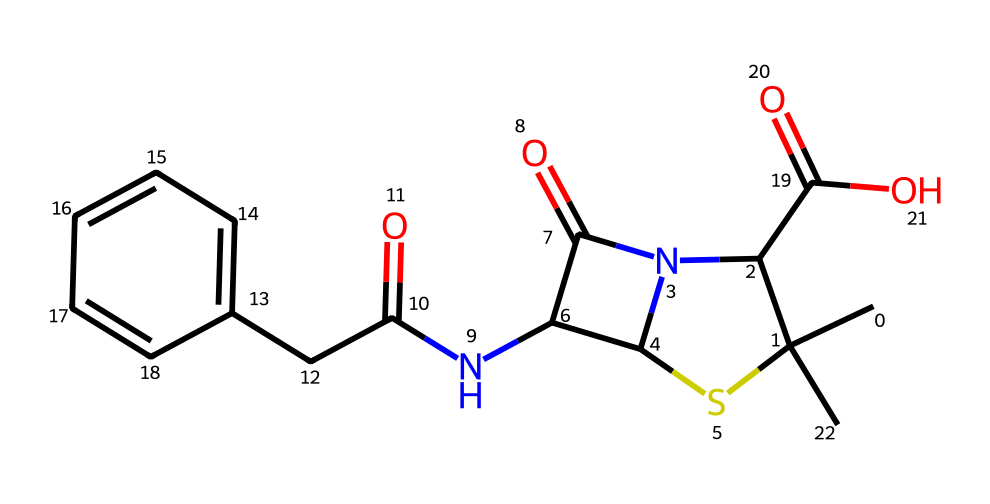What is the molecular weight of penicillin derived from this structure? To find the molecular weight, we need to first count the atoms of each element in the chemical structure represented by the SMILES notation. The structure includes carbon, hydrogen, nitrogen, oxygen, and sulfur. Calculating the weight by multiplying the number of each atom by its atomic weight and summing them up will give the molecular weight. The molecular weight of penicillin calculated from the structure is approximately 334.4 g/mol.
Answer: 334.4 g/mol How many nitrogen atoms are present in the molecular structure? By analyzing the SMILES, we can identify nitrogen atoms denoted by ‘N’. Counting the occurrences leads to identifying two nitrogen atoms in the structure of penicillin.
Answer: 2 Which functional groups are evidenced in this chemical structure? The SMILES representation reveals various functional groups, including amines (due to the nitrogen atoms bound to carbon), carboxylic acids (indicated by the carboxyl group ‘C(=O)O’), and a sulfinyl group (which is a characteristic part of organosulfur compounds). Thus, the main functional groups include amine, carboxylic acid, and sulfinyl.
Answer: amine, carboxylic acid, sulfinyl What is the impact of the sulfur atom's presence in the structure? The sulfur atom within the chemical structure contributes to the classification of penicillin as an organosulfur compound. It also impacts the reactivity and pharmacological activity of the antibiotic, contributing to the stability and overall function of the penicillin molecule in bacterial cell wall synthesis inhibition.
Answer: reactivity and pharmacological activity What is the significance of the beta-lactam ring in penicillin? The beta-lactam ring is a crucial structural feature of penicillin, allowing it to inhibit bacterial cell wall synthesis. It identifies the compound as a beta-lactam antibiotic, which is effective against certain bacterial infections. The presence of this ring affects both the mechanism of action and the spectrum of antimicrobial activity.
Answer: antibiotic activity 